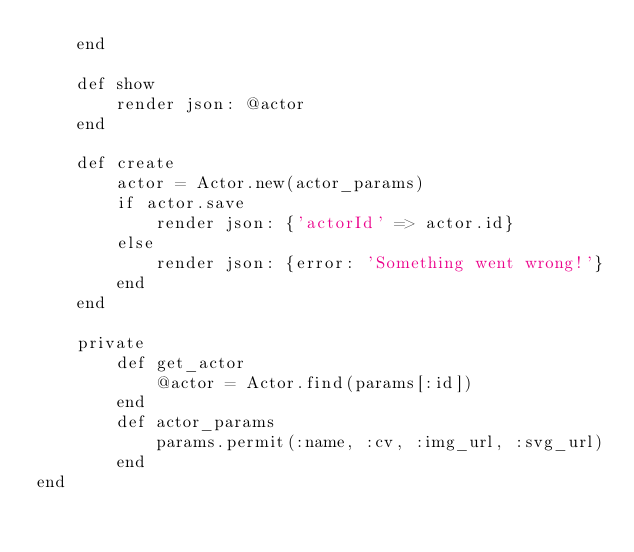<code> <loc_0><loc_0><loc_500><loc_500><_Ruby_>    end

    def show
        render json: @actor
    end

    def create
        actor = Actor.new(actor_params)
        if actor.save
            render json: {'actorId' => actor.id}
        else
            render json: {error: 'Something went wrong!'}
        end
    end

    private
        def get_actor
            @actor = Actor.find(params[:id])
        end
        def actor_params
            params.permit(:name, :cv, :img_url, :svg_url)
        end
end
</code> 